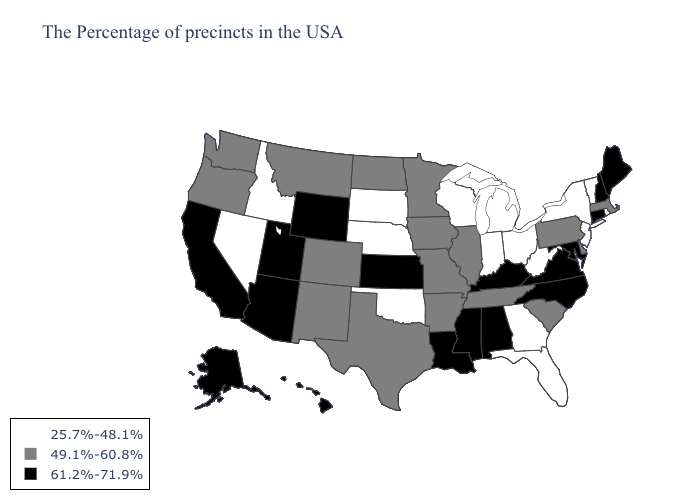Does Nebraska have a lower value than Iowa?
Keep it brief. Yes. Among the states that border Idaho , which have the lowest value?
Write a very short answer. Nevada. Does Oregon have the highest value in the USA?
Concise answer only. No. Name the states that have a value in the range 49.1%-60.8%?
Short answer required. Massachusetts, Delaware, Pennsylvania, South Carolina, Tennessee, Illinois, Missouri, Arkansas, Minnesota, Iowa, Texas, North Dakota, Colorado, New Mexico, Montana, Washington, Oregon. Is the legend a continuous bar?
Give a very brief answer. No. What is the highest value in the Northeast ?
Be succinct. 61.2%-71.9%. What is the highest value in states that border Ohio?
Answer briefly. 61.2%-71.9%. Does Nebraska have the lowest value in the USA?
Quick response, please. Yes. Does New Hampshire have the highest value in the USA?
Quick response, please. Yes. What is the lowest value in the USA?
Short answer required. 25.7%-48.1%. Name the states that have a value in the range 61.2%-71.9%?
Keep it brief. Maine, New Hampshire, Connecticut, Maryland, Virginia, North Carolina, Kentucky, Alabama, Mississippi, Louisiana, Kansas, Wyoming, Utah, Arizona, California, Alaska, Hawaii. Among the states that border Nevada , which have the highest value?
Give a very brief answer. Utah, Arizona, California. What is the lowest value in the USA?
Concise answer only. 25.7%-48.1%. Among the states that border Texas , does Oklahoma have the lowest value?
Concise answer only. Yes. How many symbols are there in the legend?
Give a very brief answer. 3. 